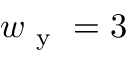<formula> <loc_0><loc_0><loc_500><loc_500>w _ { y } = 3</formula> 